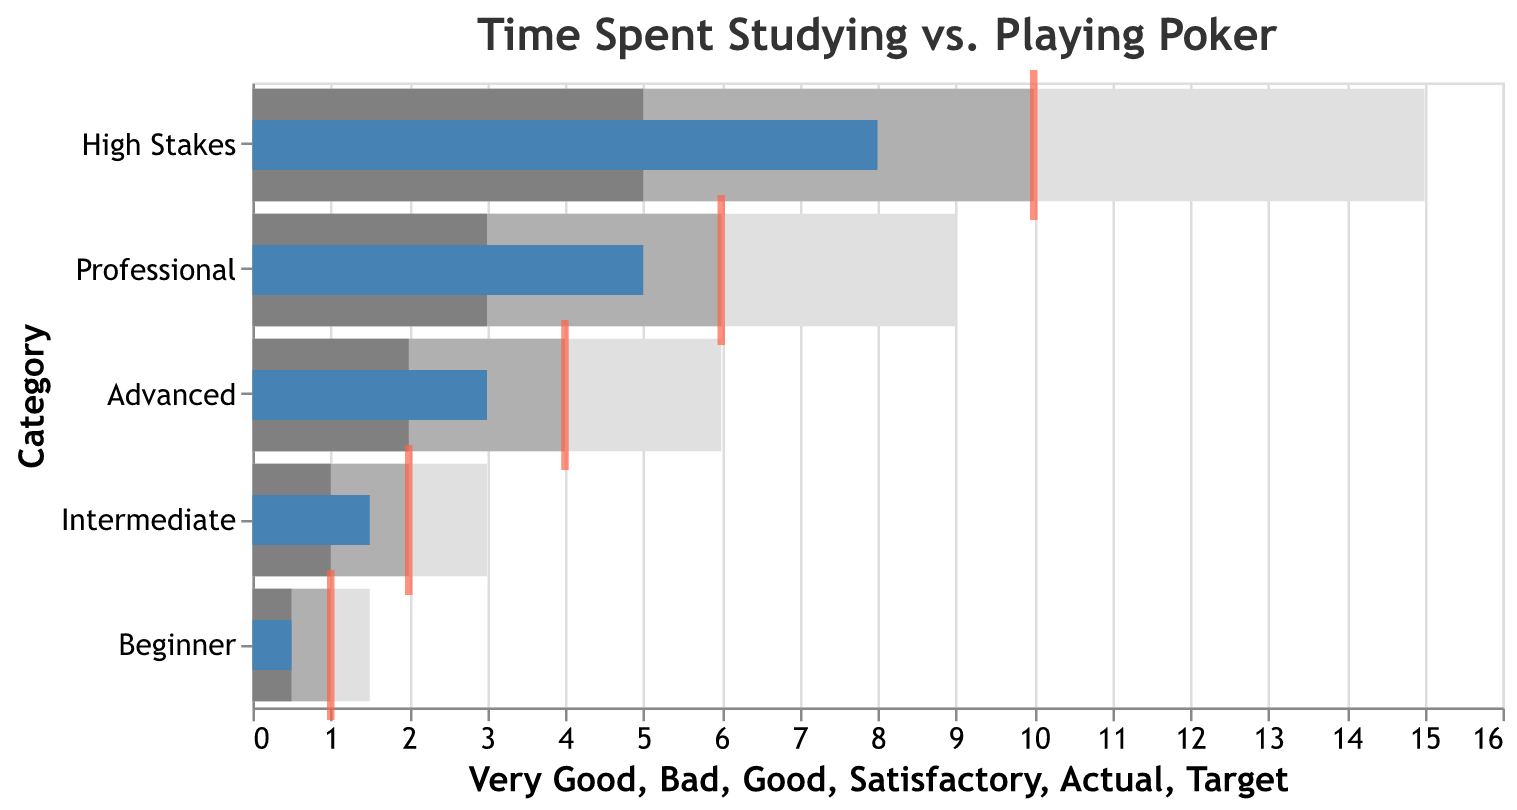What is the title of the chart? The title of the chart is displayed at the top of the figure in larger font and provides a summary of what the chart is about.
Answer: Time Spent Studying vs. Playing Poker Which category has the highest actual study time? By looking at the blue bars representing 'Actual' time across all categories, the 'High Stakes' category has the longest bar.
Answer: High Stakes What is the target time for an Intermediate player? The target times are indicated by red ticks, and by locating the red tick in the row labeled 'Intermediate,' you can see the value.
Answer: 2 How does the actual study time of a Professional compare to their target time? The blue bar for 'Professional' shows the actual time is 5, while the red tick, indicating the target time, shows 6. Therefore, the actual study time is less than the target time.
Answer: Less than the target time Is there any category where the actual study time equals the target time? By comparing the blue bars (Actual) to the red ticks (Target) for each category, none of the actual times match the target times exactly.
Answer: No What is the satisfactory range for a Beginner? The satisfactory range is shown by the middle shade of gray, spanning from the 'Bad' value up to the 'Satisfactory' value which for Beginner extends from 0 to 0.5.
Answer: 0 to 0.5 In which category is the gap between Actual and Target the largest? Calculate the difference between Actual and Target for each category: Beginner (0.5), Intermediate (0.5), Advanced (1), Professional (1), High Stakes (2). The largest gap is in the 'High Stakes' category.
Answer: High Stakes What is the visual color used for representing the 'Very Good' range? The 'Very Good' range is represented by the lightest shade of gray in the chart.
Answer: Light gray Compare the satisfactory ranges of Advanced and Professional categories. Which one is higher? The satisfactory ranges extend from 'Bad' to 'Good': Advanced (0-2), Professional (0-3). Therefore, the satisfactory range for Professional is higher.
Answer: Professional Which category has an actual study time that falls within the 'Good' range? Looking at the blue bars to see where they fall, the 'Intermediate' category falls within its 'Good' range of 1 to 2.
Answer: Intermediate 